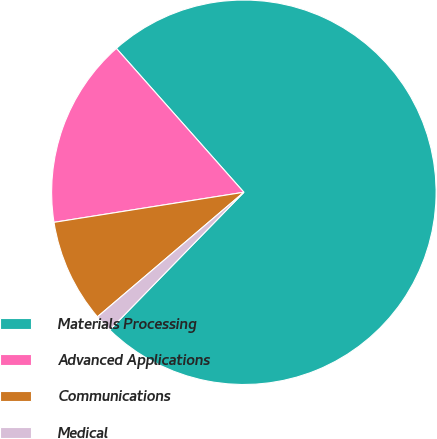Convert chart. <chart><loc_0><loc_0><loc_500><loc_500><pie_chart><fcel>Materials Processing<fcel>Advanced Applications<fcel>Communications<fcel>Medical<nl><fcel>73.83%<fcel>15.96%<fcel>8.72%<fcel>1.49%<nl></chart> 